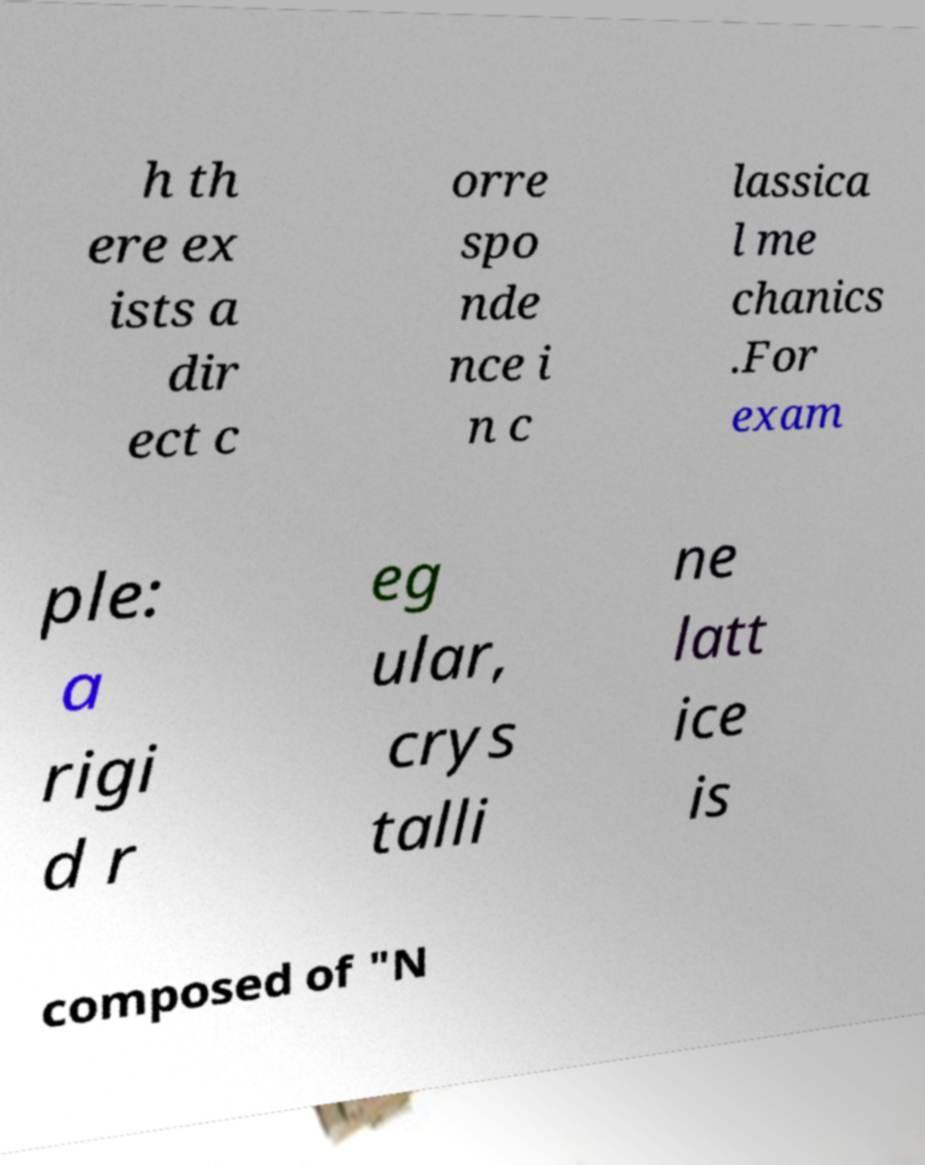Please identify and transcribe the text found in this image. h th ere ex ists a dir ect c orre spo nde nce i n c lassica l me chanics .For exam ple: a rigi d r eg ular, crys talli ne latt ice is composed of "N 